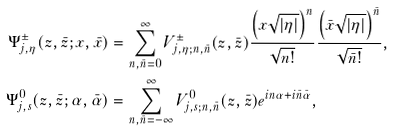<formula> <loc_0><loc_0><loc_500><loc_500>\Psi ^ { \pm } _ { j , \eta } ( z , \bar { z } ; x , \bar { x } ) & = \sum _ { n , \bar { n } = 0 } ^ { \infty } V ^ { \pm } _ { j , \eta ; n , \bar { n } } ( z , \bar { z } ) \frac { \left ( x \sqrt { | \eta | } \right ) ^ { n } } { \sqrt { n ! } } \frac { \left ( \bar { x } \sqrt { | \eta | } \right ) ^ { \bar { n } } } { \sqrt { \bar { n } ! } } , \\ \Psi ^ { 0 } _ { j , s } ( z , \bar { z } ; \alpha , \bar { \alpha } ) & = \sum _ { n , \bar { n } = - \infty } ^ { \infty } V ^ { 0 } _ { j , s ; n , \bar { n } } ( z , \bar { z } ) e ^ { i n \alpha + i \bar { n } \bar { \alpha } } ,</formula> 